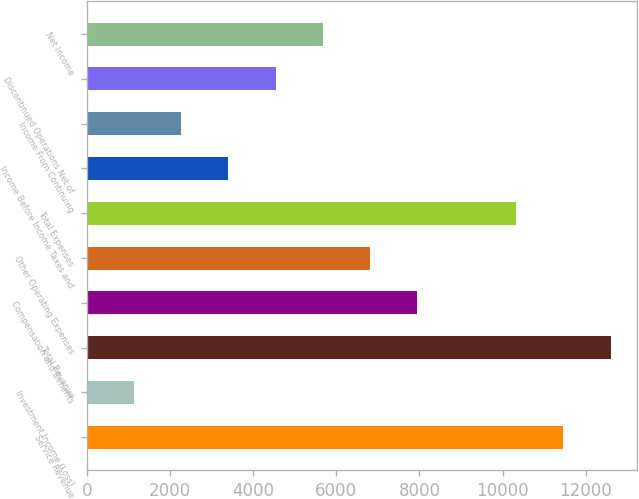Convert chart. <chart><loc_0><loc_0><loc_500><loc_500><bar_chart><fcel>Service Revenue<fcel>Investment Income (Loss)<fcel>Total Revenue<fcel>Compensation and Benefits<fcel>Other Operating Expenses<fcel>Total Expenses<fcel>Income Before Income Taxes and<fcel>Income From Continuing<fcel>Discontinued Operations Net of<fcel>Net Income<nl><fcel>11465.9<fcel>1135.68<fcel>12600.8<fcel>7945.2<fcel>6810.28<fcel>10331<fcel>3405.52<fcel>2270.6<fcel>4540.44<fcel>5675.36<nl></chart> 